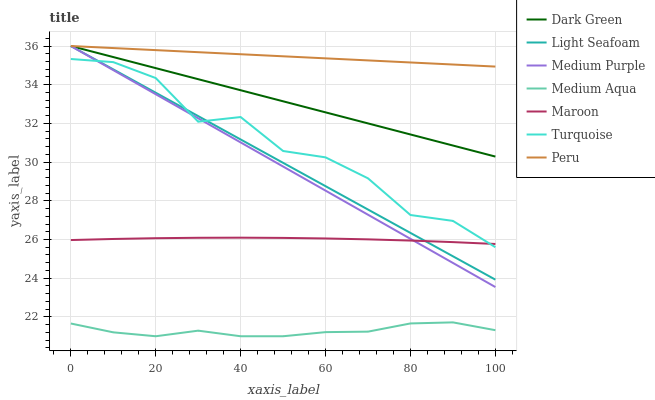Does Medium Aqua have the minimum area under the curve?
Answer yes or no. Yes. Does Peru have the maximum area under the curve?
Answer yes or no. Yes. Does Maroon have the minimum area under the curve?
Answer yes or no. No. Does Maroon have the maximum area under the curve?
Answer yes or no. No. Is Peru the smoothest?
Answer yes or no. Yes. Is Turquoise the roughest?
Answer yes or no. Yes. Is Maroon the smoothest?
Answer yes or no. No. Is Maroon the roughest?
Answer yes or no. No. Does Maroon have the lowest value?
Answer yes or no. No. Does Dark Green have the highest value?
Answer yes or no. Yes. Does Maroon have the highest value?
Answer yes or no. No. Is Medium Aqua less than Maroon?
Answer yes or no. Yes. Is Turquoise greater than Medium Aqua?
Answer yes or no. Yes. Does Medium Purple intersect Maroon?
Answer yes or no. Yes. Is Medium Purple less than Maroon?
Answer yes or no. No. Is Medium Purple greater than Maroon?
Answer yes or no. No. Does Medium Aqua intersect Maroon?
Answer yes or no. No. 